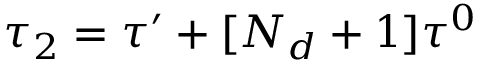<formula> <loc_0><loc_0><loc_500><loc_500>\tau _ { 2 } = \tau ^ { \prime } + [ N _ { d } + 1 ] \tau ^ { 0 }</formula> 